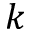<formula> <loc_0><loc_0><loc_500><loc_500>k</formula> 